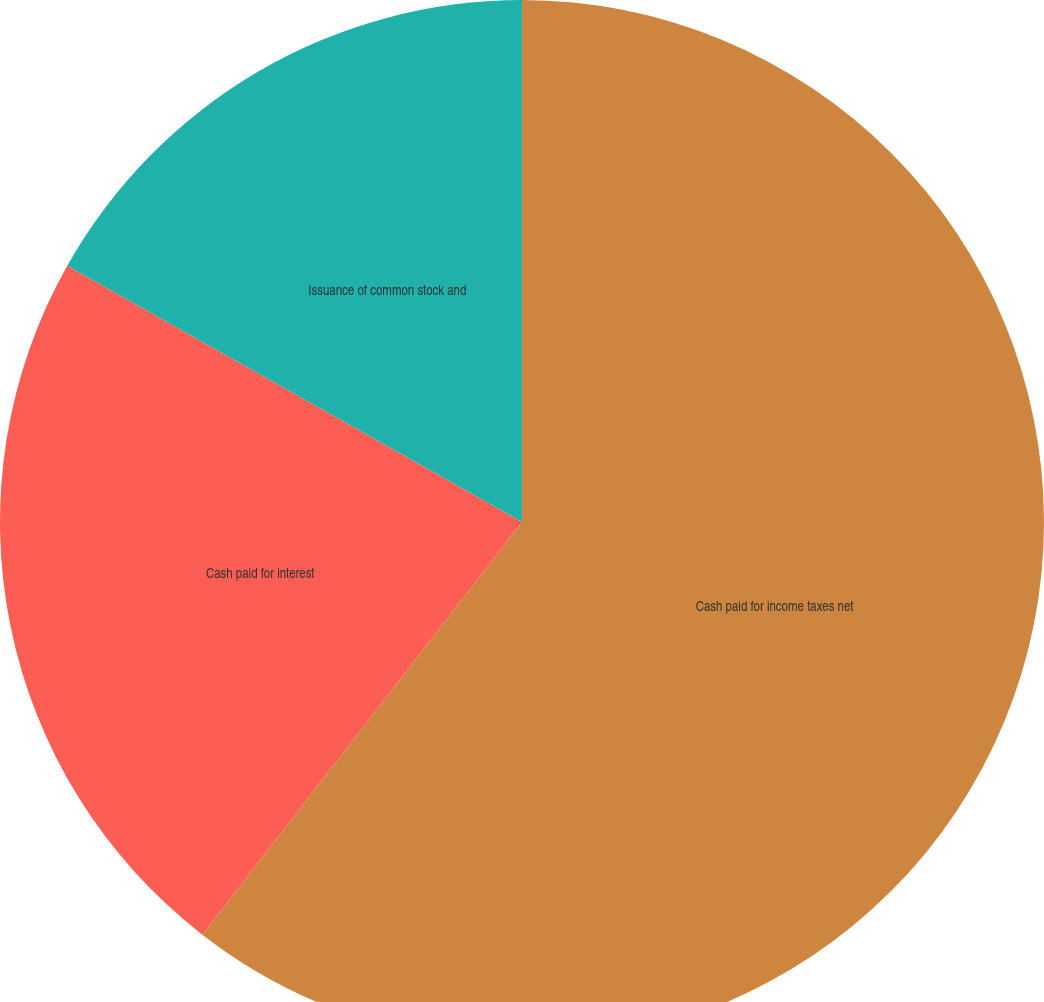Convert chart to OTSL. <chart><loc_0><loc_0><loc_500><loc_500><pie_chart><fcel>Cash paid for income taxes net<fcel>Cash paid for interest<fcel>Issuance of common stock and<nl><fcel>60.49%<fcel>22.68%<fcel>16.83%<nl></chart> 